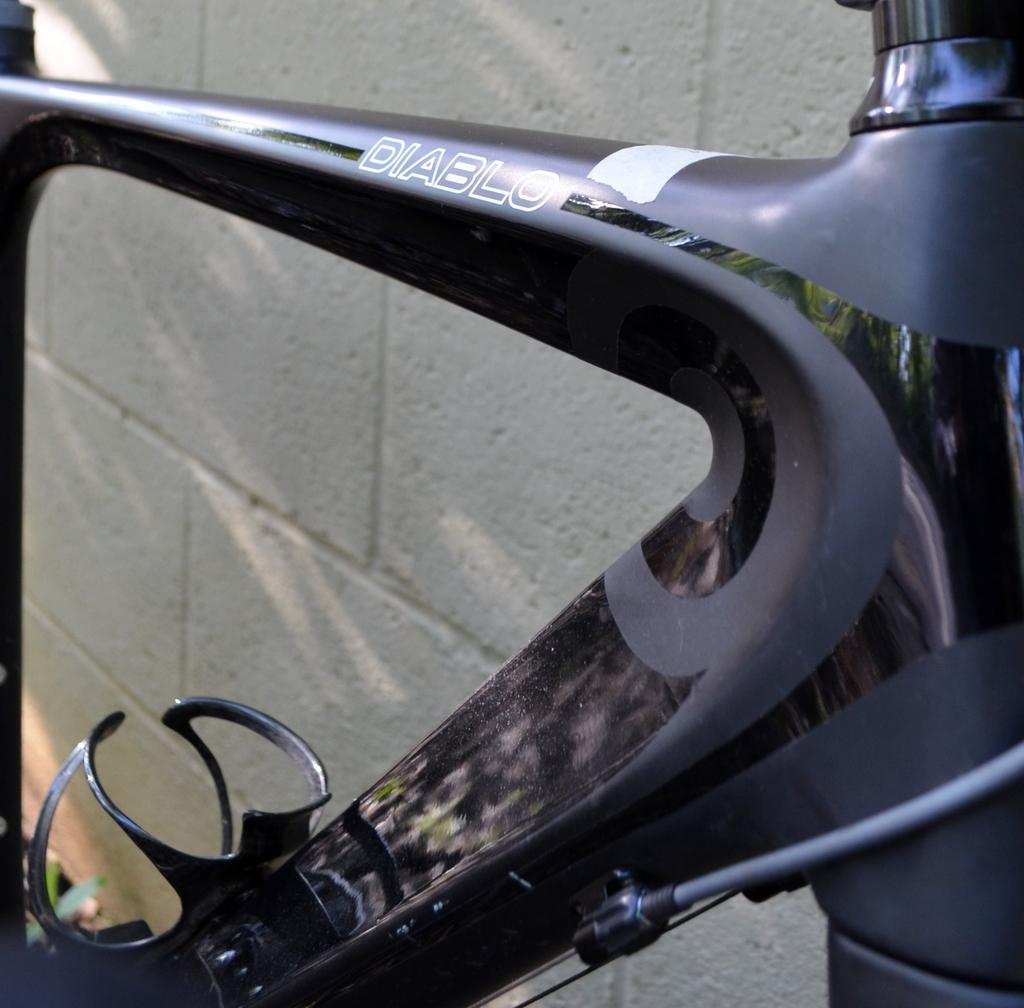What object related to transportation can be seen in the image? There is a part of a bicycle in the image. What structure is visible behind the bicycle in the image? There is a wall visible at the back of the bicycle in the image. Can you see a drum being played by a flock of dolls in the image? There is no drum or dolls present in the image. 